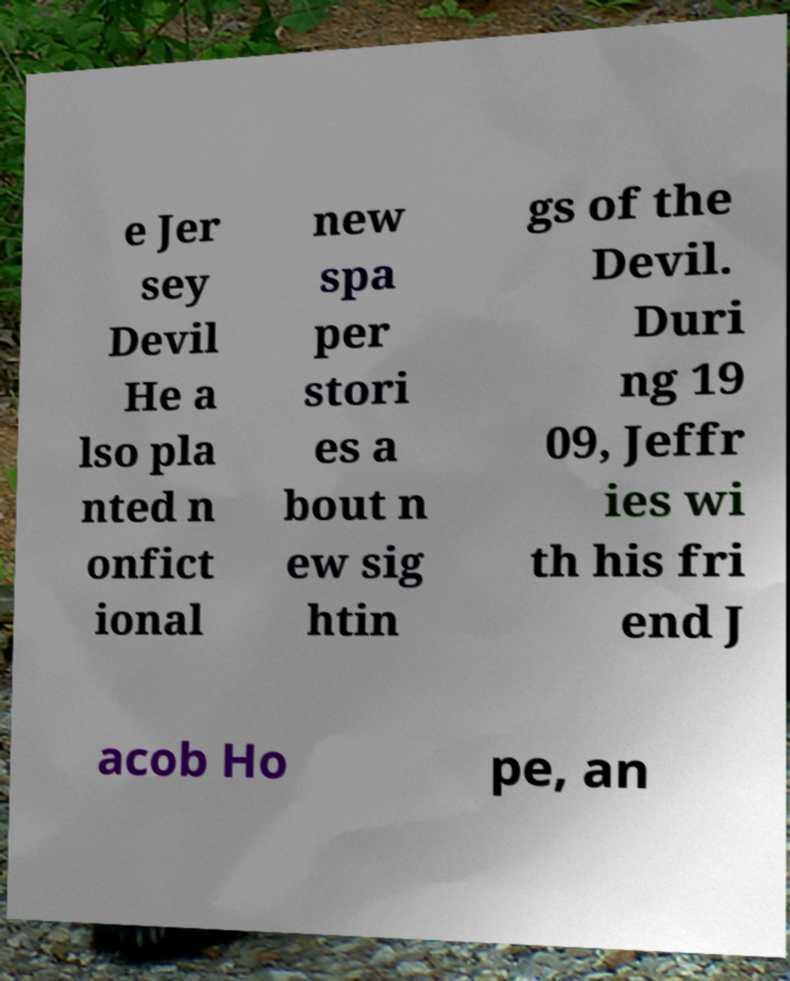What messages or text are displayed in this image? I need them in a readable, typed format. e Jer sey Devil He a lso pla nted n onfict ional new spa per stori es a bout n ew sig htin gs of the Devil. Duri ng 19 09, Jeffr ies wi th his fri end J acob Ho pe, an 